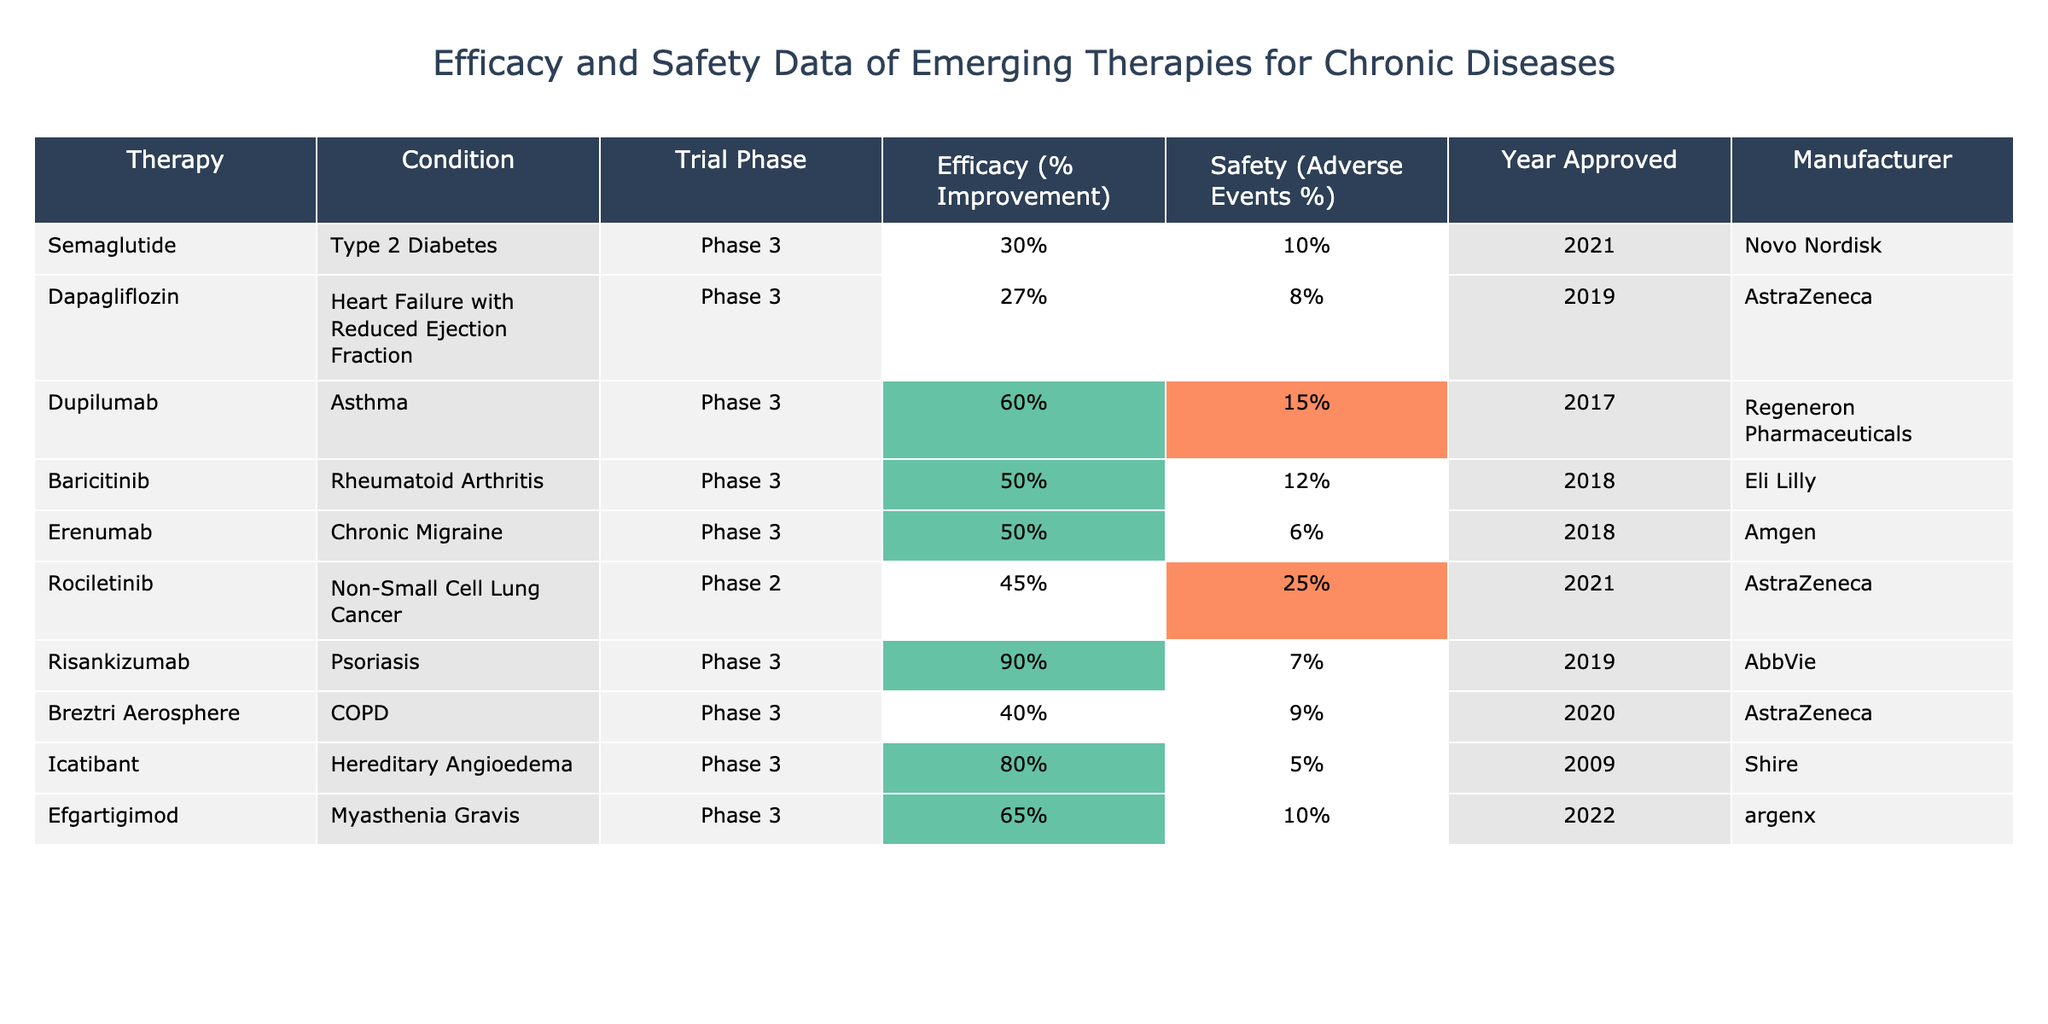What is the efficacy percentage of Dupilumab for asthma? In the table, I locate the row for Dupilumab, which shows an efficacy percentage of 60%.
Answer: 60% Which therapy has the highest efficacy improvement? By examining the table, I find that Risankizumab has the highest efficacy improvement at 90%.
Answer: 90% What is the average percentage of adverse events for therapies in Phase 3? I identify all Phase 3 therapies: Semaglutide (10%), Dapagliflozin (8%), Dupilumab (15%), Baricitinib (12%), Erenumab (6%), Risankizumab (7%), Breztri Aerosphere (9%), Icatibant (5%), and Efgartigimod (10%). The sum is (10 + 8 + 15 + 12 + 6 + 7 + 9 + 5 + 10) = 82%. There are 9 therapies, so the average is 82/9 ≈ 9.11%.
Answer: Approximately 9.11% Is Erenumab associated with a higher safety percentage of adverse events than Icatibant? I compare the adverse events percentages: Erenumab has 6% and Icatibant has 5%. Since 6% is greater than 5%, the statement is true.
Answer: Yes How does the efficacy improvement of Rociletinib compare to that of Baricitinib? Rociletinib has an efficacy improvement of 45% while Baricitinib has 50%. I find that 50% (Baricitinib) is greater than 45% (Rociletinib). Therefore, Baricitinib has a higher efficacy improvement.
Answer: Baricitinib is higher Which manufacturer has the therapy with the lowest safety percentage? I review the safety percentages: Semaglutide (10%), Dapagliflozin (8%), Dupilumab (15%), Baricitinib (12%), Erenumab (6%), Rociletinib (25%), Risankizumab (7%), Breztri Aerosphere (9%), Icatibant (5%), and Efgartigimod (10%). The lowest safety percentage is 5% for Icatibant, which is manufactured by Shire.
Answer: Shire What percentage improvement is needed for a therapy to be highlighted in green in this table? I observe that therapies are highlighted in green if their efficacy is 50% or greater. Hence, a therapy needs at least a 50% improvement to be highlighted in green.
Answer: 50% What is the difference in efficacy improvement between the therapy with the highest and lowest efficacy? The therapy with the highest efficacy is Risankizumab at 90% and the lowest is Semaglutide at 30%. The difference is 90% - 30% = 60%.
Answer: 60% Is there a therapy that has both high efficacy (≥ 50%) and low safety (≤ 10%)? I look for therapies with both conditions. Risankizumab (90%) and Icatibant (80%) meet the efficacy criteria and both have safety percentages of 7% and 5% respectively, which are below 10%. Therefore, both satisfy the conditions.
Answer: Yes Which condition has the therapy with the highest rate of adverse events? Reviewing the table, Rociletinib, for Non-Small Cell Lung Cancer, has the highest rate of adverse events at 25%.
Answer: Non-Small Cell Lung Cancer 